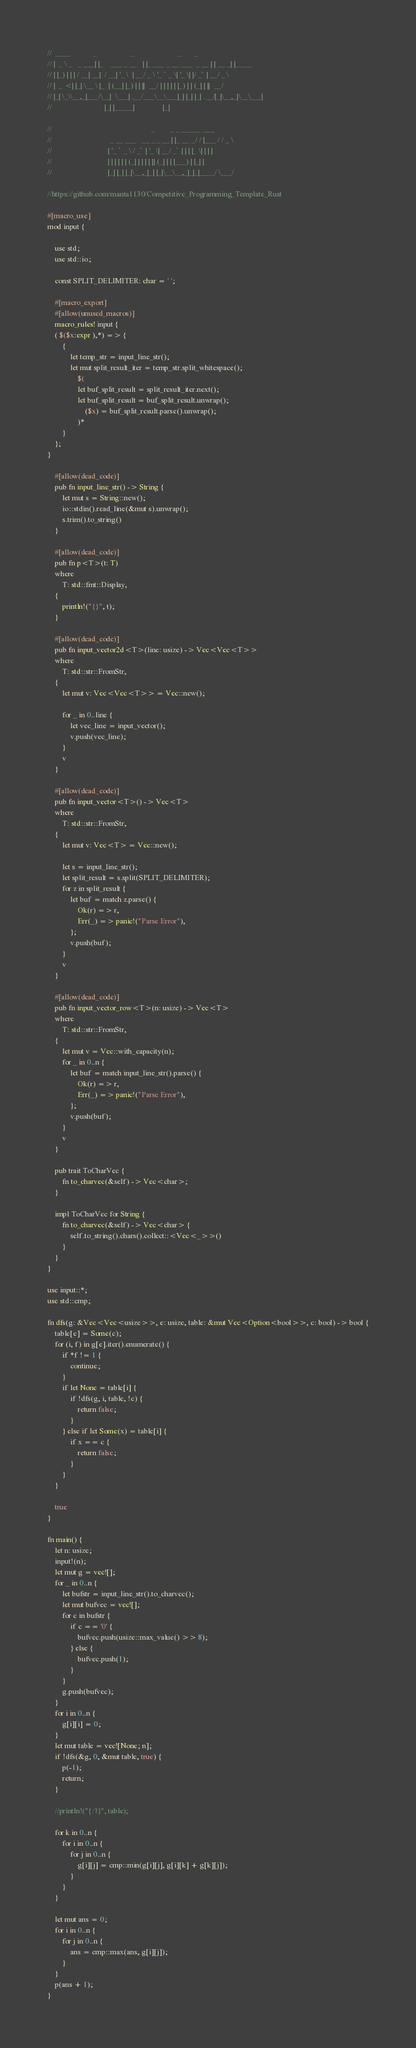Convert code to text. <code><loc_0><loc_0><loc_500><loc_500><_Rust_>//  ____            _                  _                       _       _
// |  _ \ _   _ ___| |_    ___ _ __   | |_ ___ _ __ ___  _ __ | | __ _| |_ ___
// | |_) | | | / __| __|  / __| '_ \  | __/ _ \ '_ ` _ \| '_ \| |/ _` | __/ _ \
// |  _ <| |_| \__ \ |_  | (__| |_) | | ||  __/ | | | | | |_) | | (_| | ||  __/
// |_| \_\\__,_|___/\__|  \___| .__/___\__\___|_| |_| |_| .__/|_|\__,_|\__\___|
//                            |_| |_____|               |_|

//                                                     _        _ _ _____  ___
//                               _ __ ___   __ _ _ __ | |_ __ _/ / |___ / / _ \
//                              | '_ ` _ \ / _` | '_ \| __/ _` | | | |_ \| | | |
//                              | | | | | | (_| | | | | || (_| | | |___) | |_| |
//                              |_| |_| |_|\__,_|_| |_|\__\__,_|_|_|____/ \___/

//https://github.com/manta1130/Competitive_Programming_Template_Rust

#[macro_use]
mod input {

    use std;
    use std::io;

    const SPLIT_DELIMITER: char = ' ';

    #[macro_export]
    #[allow(unused_macros)]
    macro_rules! input {
    ( $($x:expr ),*) => {
        {
            let temp_str = input_line_str();
            let mut split_result_iter = temp_str.split_whitespace();
                $(
                let buf_split_result = split_result_iter.next();
                let buf_split_result = buf_split_result.unwrap();
                    ($x) = buf_split_result.parse().unwrap();
                )*
        }
    };
}

    #[allow(dead_code)]
    pub fn input_line_str() -> String {
        let mut s = String::new();
        io::stdin().read_line(&mut s).unwrap();
        s.trim().to_string()
    }

    #[allow(dead_code)]
    pub fn p<T>(t: T)
    where
        T: std::fmt::Display,
    {
        println!("{}", t);
    }

    #[allow(dead_code)]
    pub fn input_vector2d<T>(line: usize) -> Vec<Vec<T>>
    where
        T: std::str::FromStr,
    {
        let mut v: Vec<Vec<T>> = Vec::new();

        for _ in 0..line {
            let vec_line = input_vector();
            v.push(vec_line);
        }
        v
    }

    #[allow(dead_code)]
    pub fn input_vector<T>() -> Vec<T>
    where
        T: std::str::FromStr,
    {
        let mut v: Vec<T> = Vec::new();

        let s = input_line_str();
        let split_result = s.split(SPLIT_DELIMITER);
        for z in split_result {
            let buf = match z.parse() {
                Ok(r) => r,
                Err(_) => panic!("Parse Error"),
            };
            v.push(buf);
        }
        v
    }

    #[allow(dead_code)]
    pub fn input_vector_row<T>(n: usize) -> Vec<T>
    where
        T: std::str::FromStr,
    {
        let mut v = Vec::with_capacity(n);
        for _ in 0..n {
            let buf = match input_line_str().parse() {
                Ok(r) => r,
                Err(_) => panic!("Parse Error"),
            };
            v.push(buf);
        }
        v
    }

    pub trait ToCharVec {
        fn to_charvec(&self) -> Vec<char>;
    }

    impl ToCharVec for String {
        fn to_charvec(&self) -> Vec<char> {
            self.to_string().chars().collect::<Vec<_>>()
        }
    }
}

use input::*;
use std::cmp;

fn dfs(g: &Vec<Vec<usize>>, e: usize, table: &mut Vec<Option<bool>>, c: bool) -> bool {
    table[e] = Some(c);
    for (i, f) in g[e].iter().enumerate() {
        if *f != 1 {
            continue;
        }
        if let None = table[i] {
            if !dfs(g, i, table, !c) {
                return false;
            }
        } else if let Some(x) = table[i] {
            if x == c {
                return false;
            }
        }
    }

    true
}

fn main() {
    let n: usize;
    input!(n);
    let mut g = vec![];
    for _ in 0..n {
        let bufstr = input_line_str().to_charvec();
        let mut bufvec = vec![];
        for c in bufstr {
            if c == '0' {
                bufvec.push(usize::max_value() >> 8);
            } else {
                bufvec.push(1);
            }
        }
        g.push(bufvec);
    }
    for i in 0..n {
        g[i][i] = 0;
    }
    let mut table = vec![None; n];
    if !dfs(&g, 0, &mut table, true) {
        p(-1);
        return;
    }

    //println!("{:?}", table);

    for k in 0..n {
        for i in 0..n {
            for j in 0..n {
                g[i][j] = cmp::min(g[i][j], g[i][k] + g[k][j]);
            }
        }
    }

    let mut ans = 0;
    for i in 0..n {
        for j in 0..n {
            ans = cmp::max(ans, g[i][j]);
        }
    }
    p(ans + 1);
}
</code> 